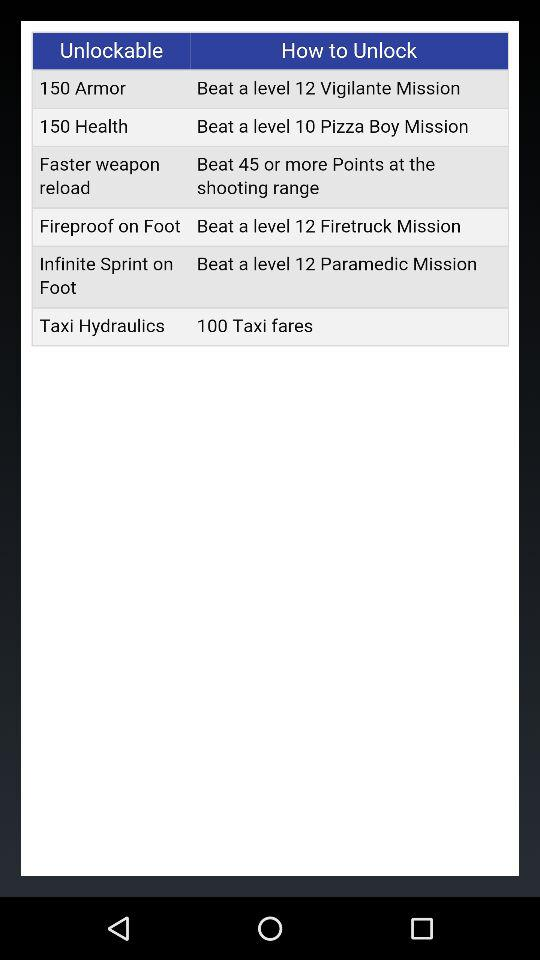How can "Taxi Hydraulics" be unlocked? "Taxi Hydraulics" can be unlocked by "100 Taxi fares". 